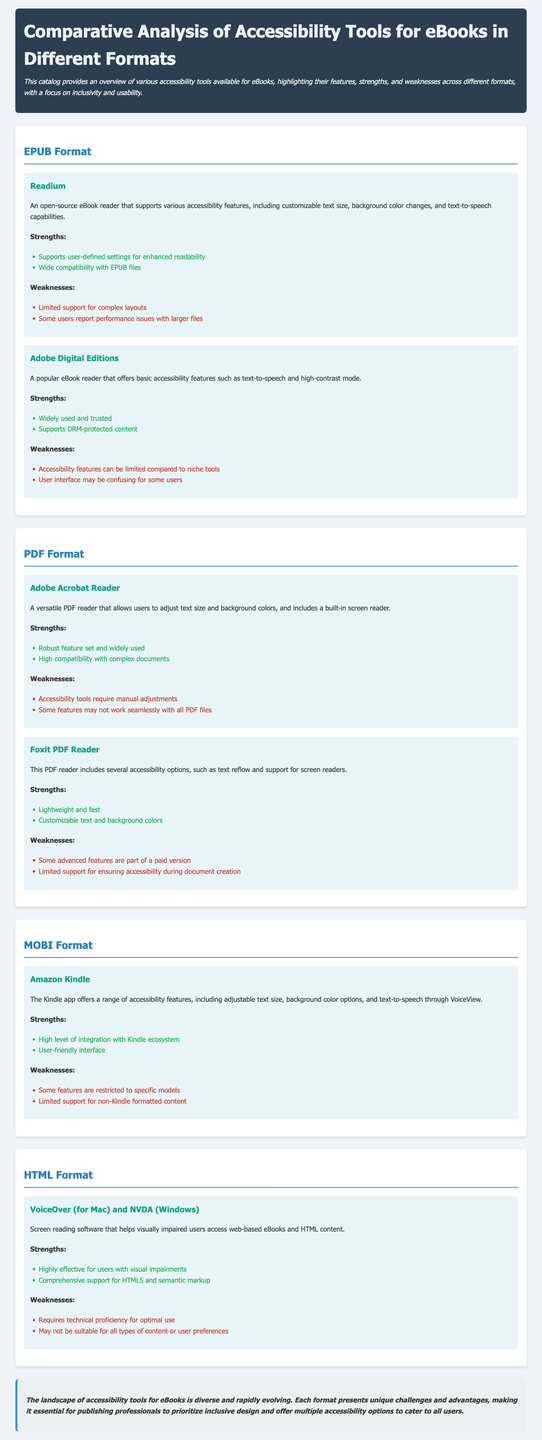What accessibility feature is included in Readium? Readium supports customizable text size, background color changes, and text-to-speech capabilities.
Answer: text-to-speech What is a weakness of Adobe Digital Editions? One of the weaknesses mentioned is that accessibility features can be limited compared to niche tools.
Answer: limited accessibility features Which tool provides screen reading for web-based eBooks? VoiceOver (for Mac) and NVDA (Windows) are screen reading software that help visually impaired users.
Answer: VoiceOver and NVDA How many strengths does the Amazon Kindle possess? The Amazon Kindle has two strengths listed: high integration with the Kindle ecosystem and a user-friendly interface.
Answer: two What type of format does Foxit PDF Reader support? Foxit PDF Reader includes accessibility options such as text reflow and screen reader support, which apply to PDFs.
Answer: PDF What is the conclusion about accessibility tools for eBooks? The conclusion highlights that the landscape of accessibility tools is diverse and evolving, essential for inclusive design.
Answer: diverse and evolving What is the primary focus of the catalog? The catalog provides an overview of various accessibility tools available for eBooks, focusing on inclusivity and usability.
Answer: inclusivity and usability What format is Readium designed to support? Readium is designed to support EPUB files specifically.
Answer: EPUB What complaint do some users have regarding Readium? Some users report performance issues with larger files when using Readium.
Answer: performance issues What does Adobe Acrobat Reader allow users to adjust? Adobe Acrobat Reader allows users to adjust text size and background colors.
Answer: text size and background colors 